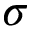<formula> <loc_0><loc_0><loc_500><loc_500>\sigma</formula> 